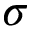<formula> <loc_0><loc_0><loc_500><loc_500>\sigma</formula> 